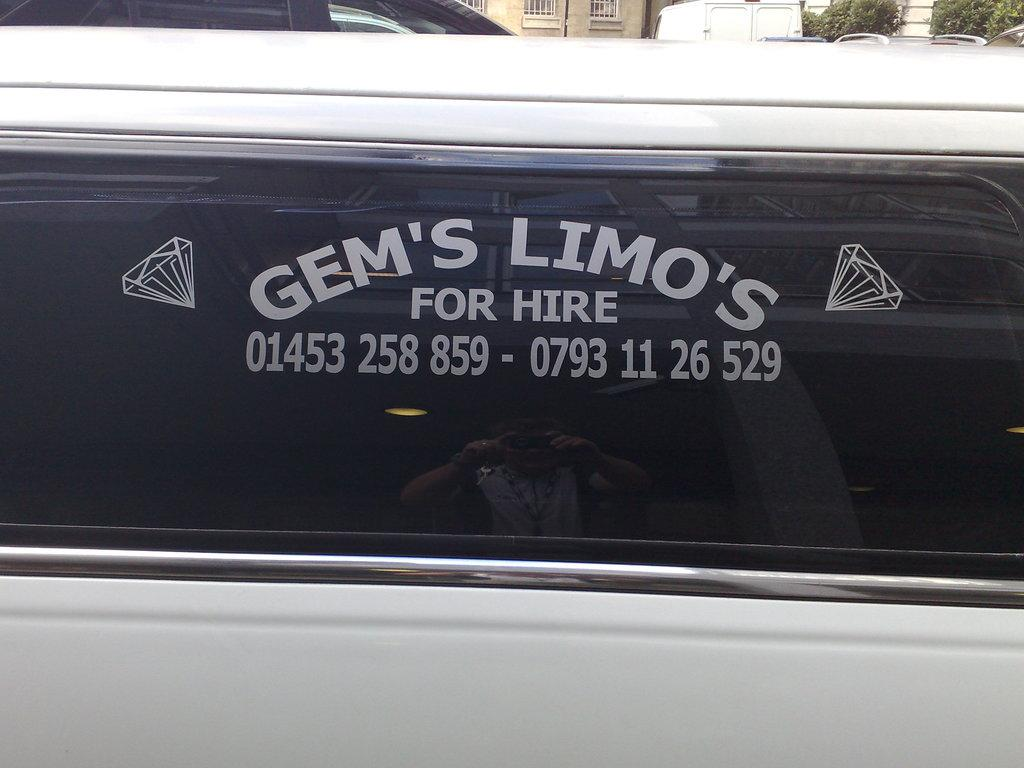What is the main object in the image? There is a board in the image. What can be found on the board? The board contains text. What type of song is being sung by the lizards on the board in the image? There are no lizards or songs present in the image; it only contains a board with text. 